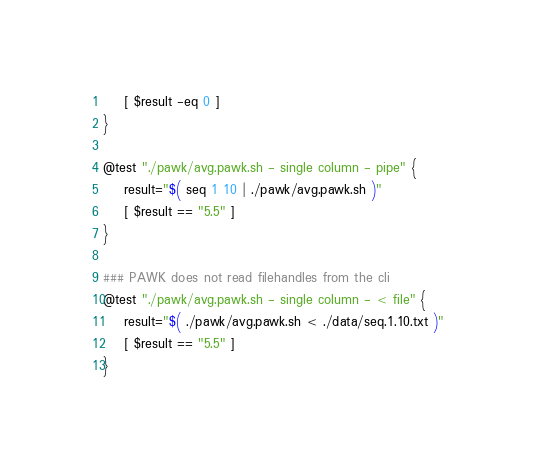Convert code to text. <code><loc_0><loc_0><loc_500><loc_500><_Bash_>    [ $result -eq 0 ]
}

@test "./pawk/avg.pawk.sh - single column - pipe" {
    result="$( seq 1 10 | ./pawk/avg.pawk.sh )"
    [ $result == "5.5" ]
}

### PAWK does not read filehandles from the cli
@test "./pawk/avg.pawk.sh - single column - < file" {
    result="$( ./pawk/avg.pawk.sh < ./data/seq.1.10.txt )"
    [ $result == "5.5" ]
}
</code> 